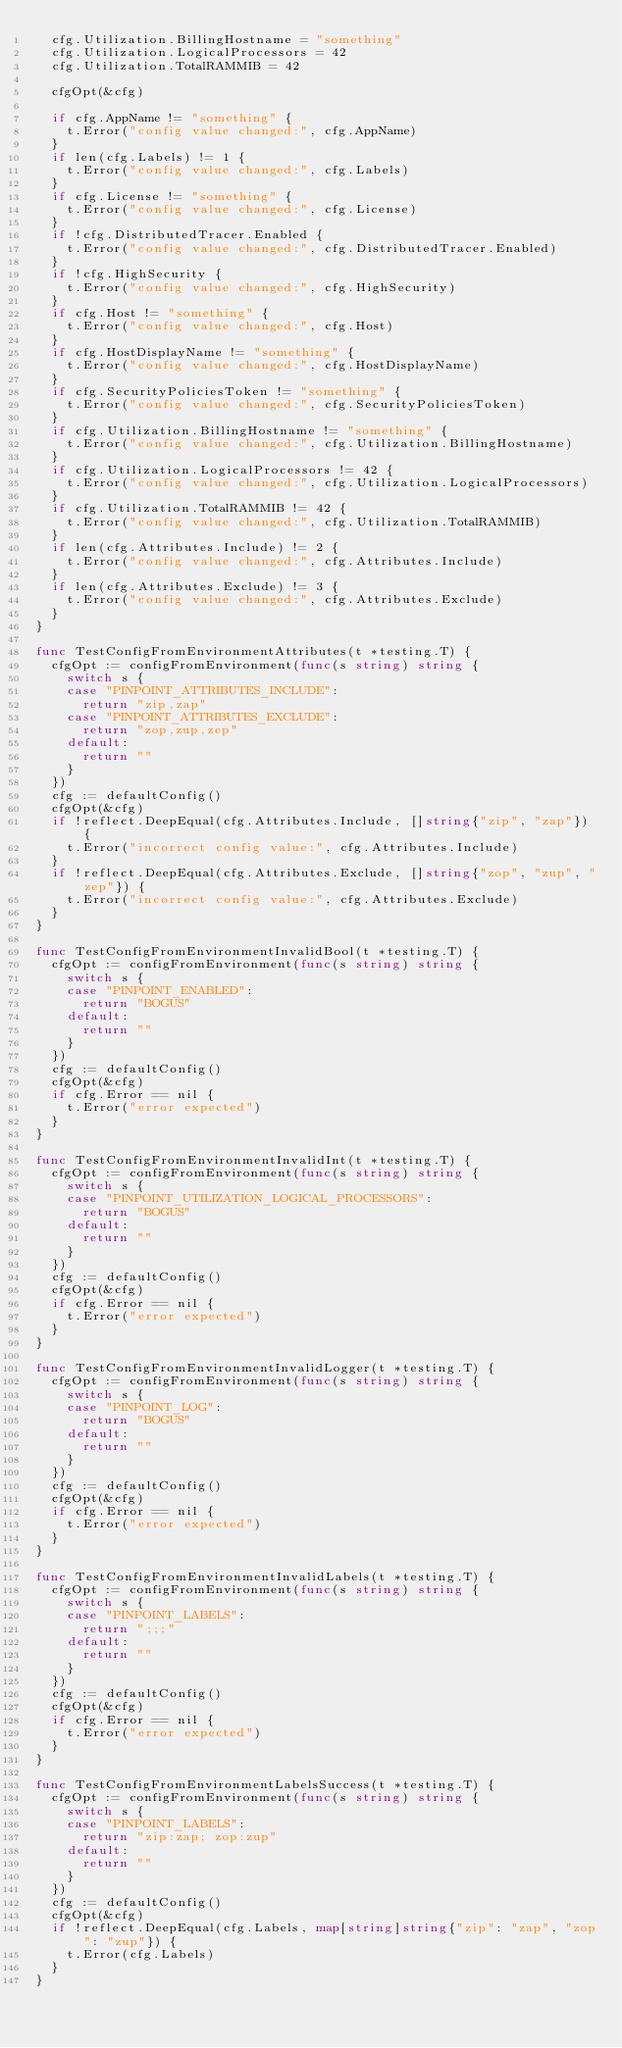Convert code to text. <code><loc_0><loc_0><loc_500><loc_500><_Go_>	cfg.Utilization.BillingHostname = "something"
	cfg.Utilization.LogicalProcessors = 42
	cfg.Utilization.TotalRAMMIB = 42

	cfgOpt(&cfg)

	if cfg.AppName != "something" {
		t.Error("config value changed:", cfg.AppName)
	}
	if len(cfg.Labels) != 1 {
		t.Error("config value changed:", cfg.Labels)
	}
	if cfg.License != "something" {
		t.Error("config value changed:", cfg.License)
	}
	if !cfg.DistributedTracer.Enabled {
		t.Error("config value changed:", cfg.DistributedTracer.Enabled)
	}
	if !cfg.HighSecurity {
		t.Error("config value changed:", cfg.HighSecurity)
	}
	if cfg.Host != "something" {
		t.Error("config value changed:", cfg.Host)
	}
	if cfg.HostDisplayName != "something" {
		t.Error("config value changed:", cfg.HostDisplayName)
	}
	if cfg.SecurityPoliciesToken != "something" {
		t.Error("config value changed:", cfg.SecurityPoliciesToken)
	}
	if cfg.Utilization.BillingHostname != "something" {
		t.Error("config value changed:", cfg.Utilization.BillingHostname)
	}
	if cfg.Utilization.LogicalProcessors != 42 {
		t.Error("config value changed:", cfg.Utilization.LogicalProcessors)
	}
	if cfg.Utilization.TotalRAMMIB != 42 {
		t.Error("config value changed:", cfg.Utilization.TotalRAMMIB)
	}
	if len(cfg.Attributes.Include) != 2 {
		t.Error("config value changed:", cfg.Attributes.Include)
	}
	if len(cfg.Attributes.Exclude) != 3 {
		t.Error("config value changed:", cfg.Attributes.Exclude)
	}
}

func TestConfigFromEnvironmentAttributes(t *testing.T) {
	cfgOpt := configFromEnvironment(func(s string) string {
		switch s {
		case "PINPOINT_ATTRIBUTES_INCLUDE":
			return "zip,zap"
		case "PINPOINT_ATTRIBUTES_EXCLUDE":
			return "zop,zup,zep"
		default:
			return ""
		}
	})
	cfg := defaultConfig()
	cfgOpt(&cfg)
	if !reflect.DeepEqual(cfg.Attributes.Include, []string{"zip", "zap"}) {
		t.Error("incorrect config value:", cfg.Attributes.Include)
	}
	if !reflect.DeepEqual(cfg.Attributes.Exclude, []string{"zop", "zup", "zep"}) {
		t.Error("incorrect config value:", cfg.Attributes.Exclude)
	}
}

func TestConfigFromEnvironmentInvalidBool(t *testing.T) {
	cfgOpt := configFromEnvironment(func(s string) string {
		switch s {
		case "PINPOINT_ENABLED":
			return "BOGUS"
		default:
			return ""
		}
	})
	cfg := defaultConfig()
	cfgOpt(&cfg)
	if cfg.Error == nil {
		t.Error("error expected")
	}
}

func TestConfigFromEnvironmentInvalidInt(t *testing.T) {
	cfgOpt := configFromEnvironment(func(s string) string {
		switch s {
		case "PINPOINT_UTILIZATION_LOGICAL_PROCESSORS":
			return "BOGUS"
		default:
			return ""
		}
	})
	cfg := defaultConfig()
	cfgOpt(&cfg)
	if cfg.Error == nil {
		t.Error("error expected")
	}
}

func TestConfigFromEnvironmentInvalidLogger(t *testing.T) {
	cfgOpt := configFromEnvironment(func(s string) string {
		switch s {
		case "PINPOINT_LOG":
			return "BOGUS"
		default:
			return ""
		}
	})
	cfg := defaultConfig()
	cfgOpt(&cfg)
	if cfg.Error == nil {
		t.Error("error expected")
	}
}

func TestConfigFromEnvironmentInvalidLabels(t *testing.T) {
	cfgOpt := configFromEnvironment(func(s string) string {
		switch s {
		case "PINPOINT_LABELS":
			return ";;;"
		default:
			return ""
		}
	})
	cfg := defaultConfig()
	cfgOpt(&cfg)
	if cfg.Error == nil {
		t.Error("error expected")
	}
}

func TestConfigFromEnvironmentLabelsSuccess(t *testing.T) {
	cfgOpt := configFromEnvironment(func(s string) string {
		switch s {
		case "PINPOINT_LABELS":
			return "zip:zap; zop:zup"
		default:
			return ""
		}
	})
	cfg := defaultConfig()
	cfgOpt(&cfg)
	if !reflect.DeepEqual(cfg.Labels, map[string]string{"zip": "zap", "zop": "zup"}) {
		t.Error(cfg.Labels)
	}
}
</code> 